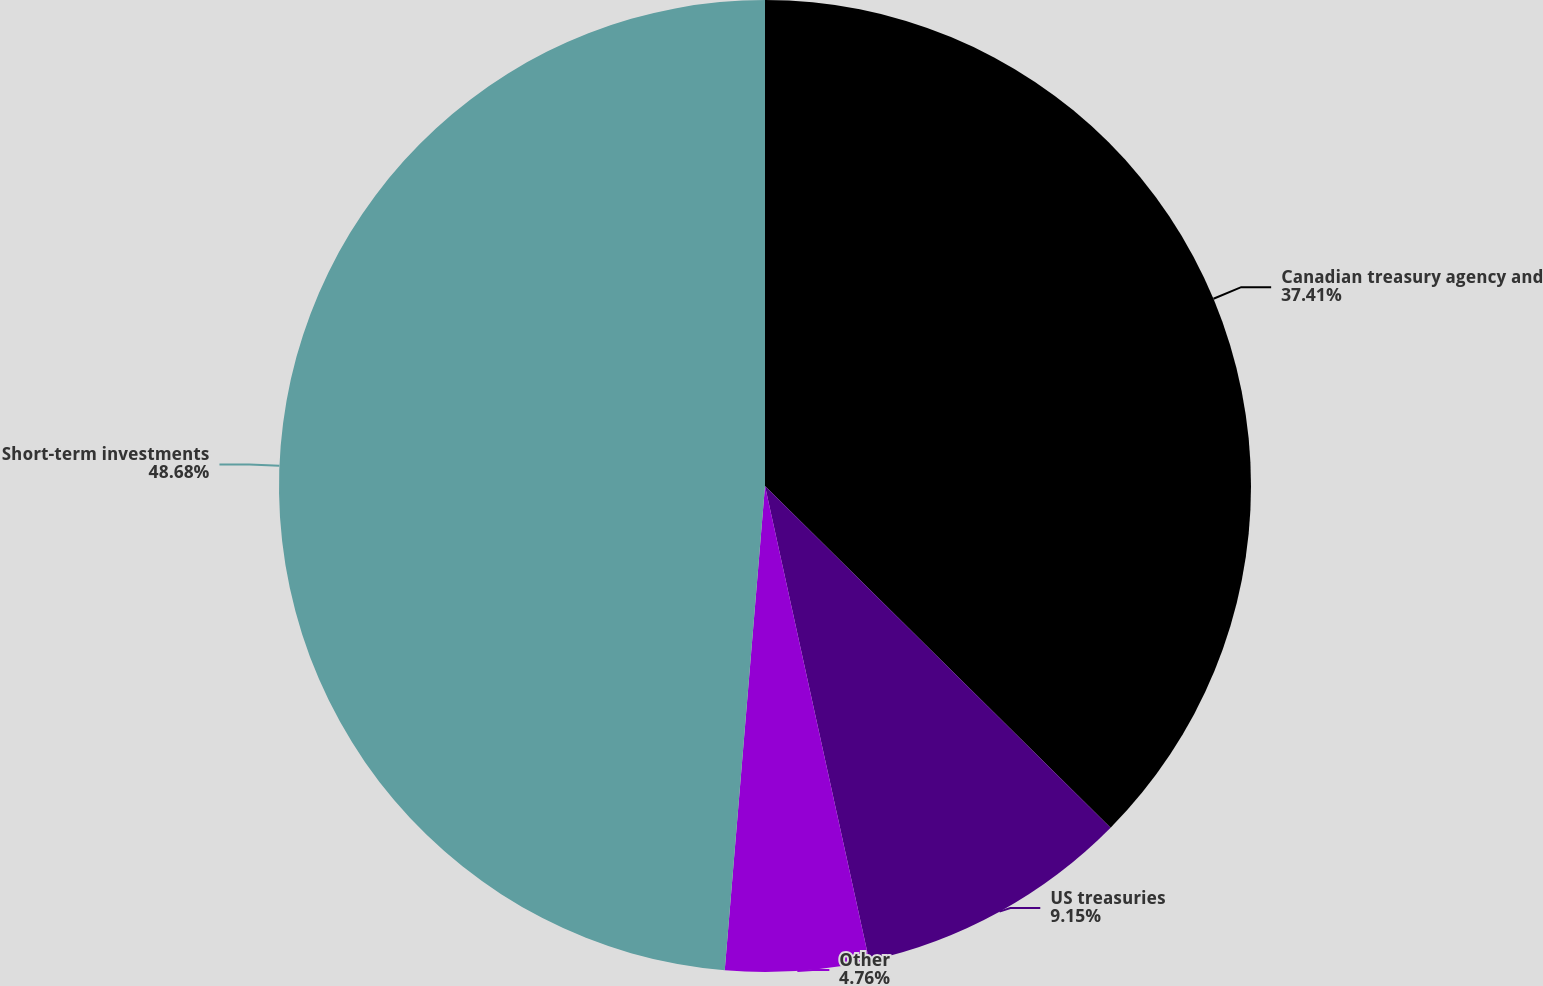Convert chart to OTSL. <chart><loc_0><loc_0><loc_500><loc_500><pie_chart><fcel>Canadian treasury agency and<fcel>US treasuries<fcel>Other<fcel>Short-term investments<nl><fcel>37.41%<fcel>9.15%<fcel>4.76%<fcel>48.68%<nl></chart> 